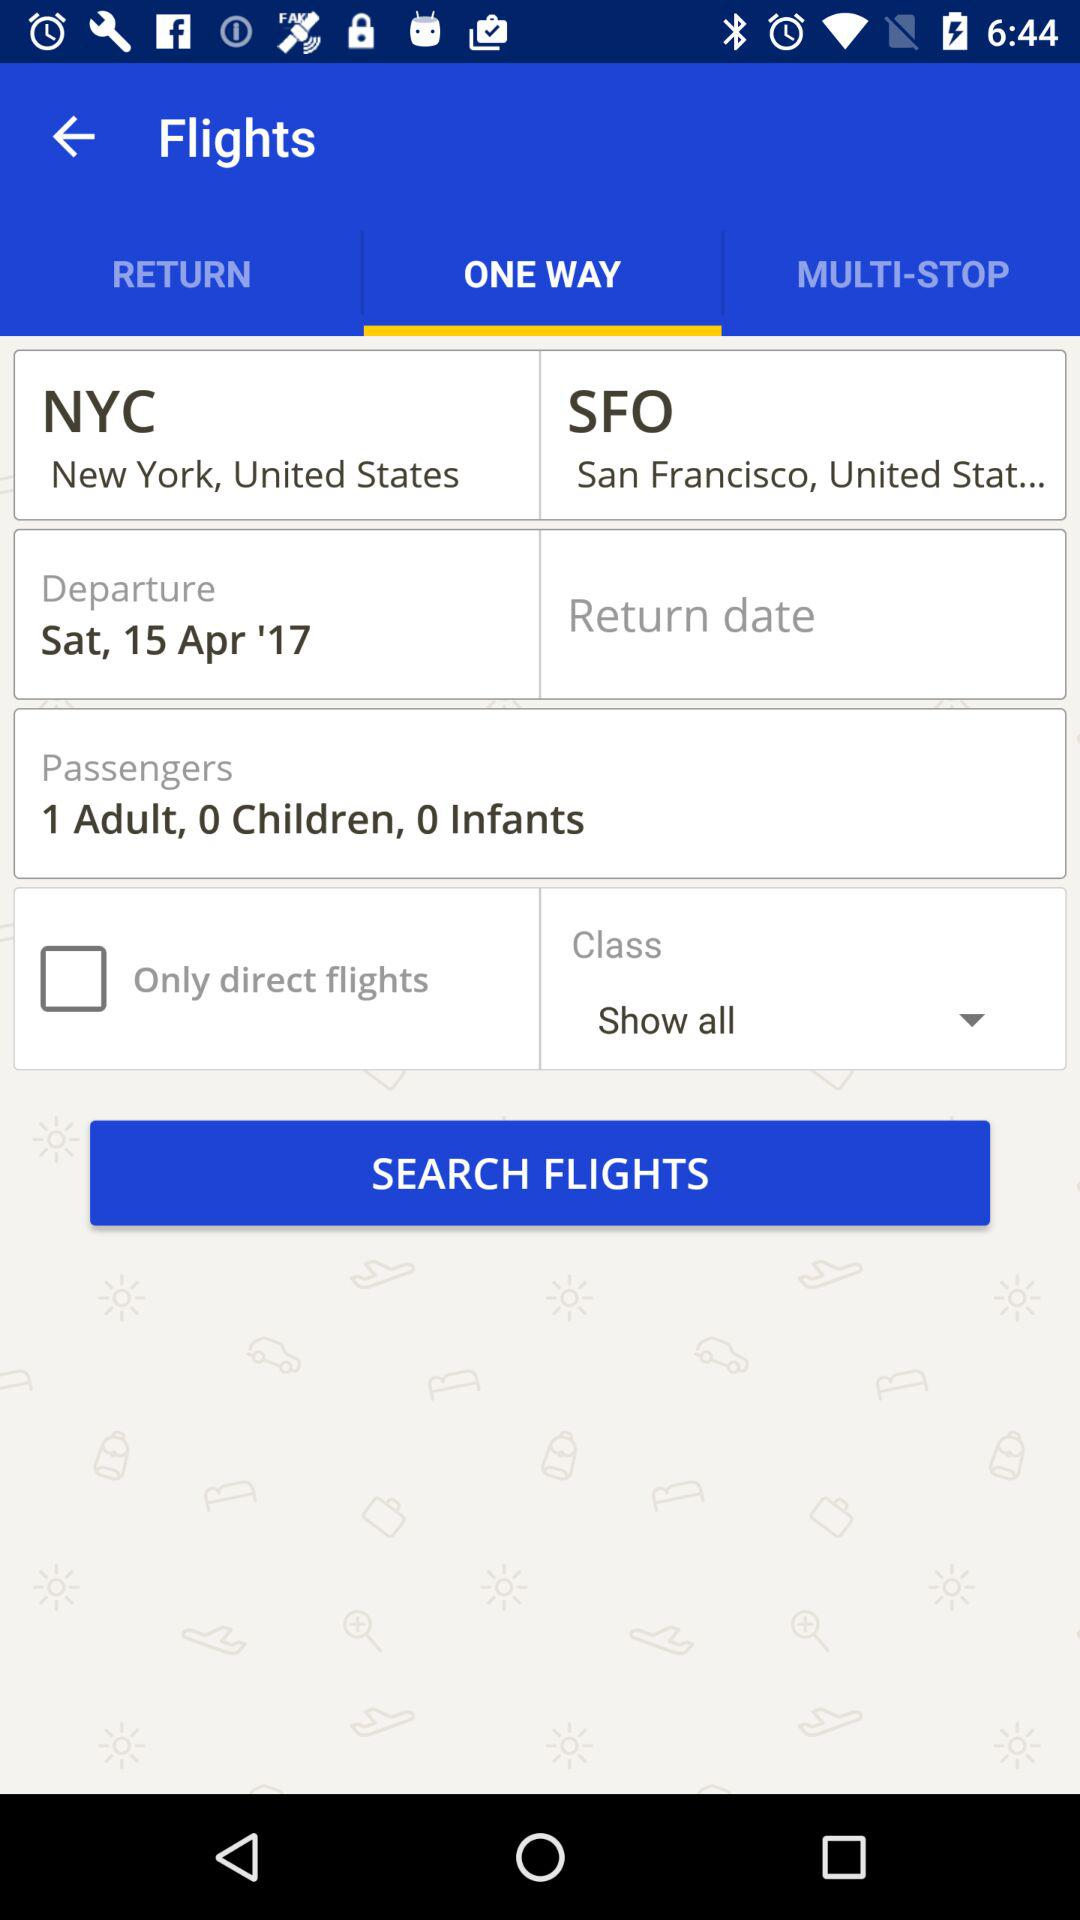What type of ticket will be booked? The type of ticket will be one-way. 